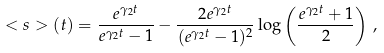<formula> <loc_0><loc_0><loc_500><loc_500>< s > ( t ) = \frac { e ^ { \gamma _ { 2 } t } } { e ^ { \gamma _ { 2 } t } - 1 } - \frac { 2 e ^ { \gamma _ { 2 } t } } { ( e ^ { \gamma _ { 2 } t } - 1 ) ^ { 2 } } \log \left ( \frac { e ^ { \gamma _ { 2 } t } + 1 } { 2 } \right ) \, ,</formula> 